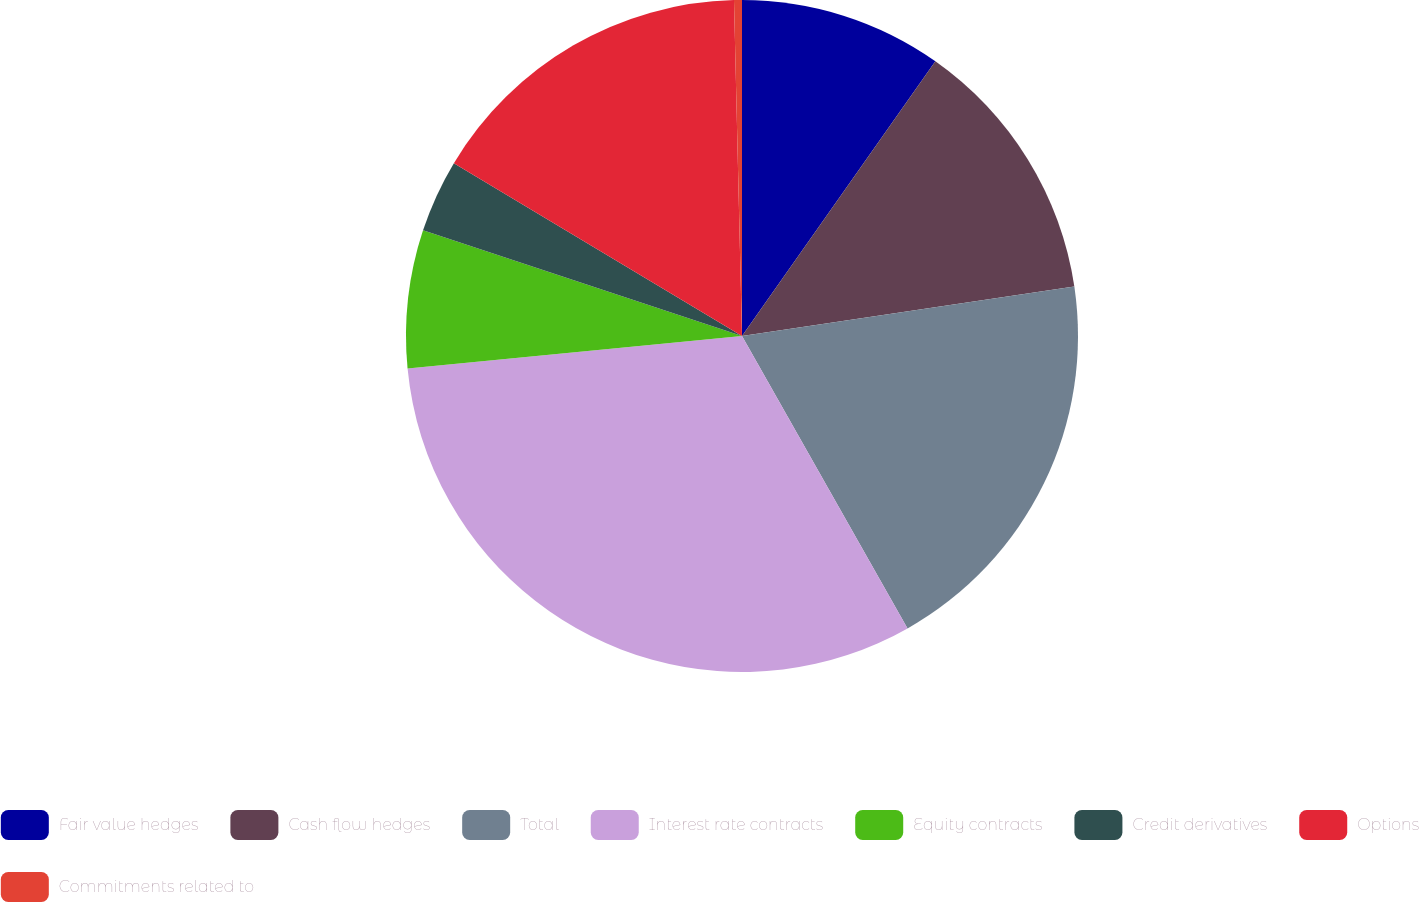Convert chart. <chart><loc_0><loc_0><loc_500><loc_500><pie_chart><fcel>Fair value hedges<fcel>Cash flow hedges<fcel>Total<fcel>Interest rate contracts<fcel>Equity contracts<fcel>Credit derivatives<fcel>Options<fcel>Commitments related to<nl><fcel>9.76%<fcel>12.89%<fcel>19.15%<fcel>31.66%<fcel>6.63%<fcel>3.51%<fcel>16.02%<fcel>0.38%<nl></chart> 